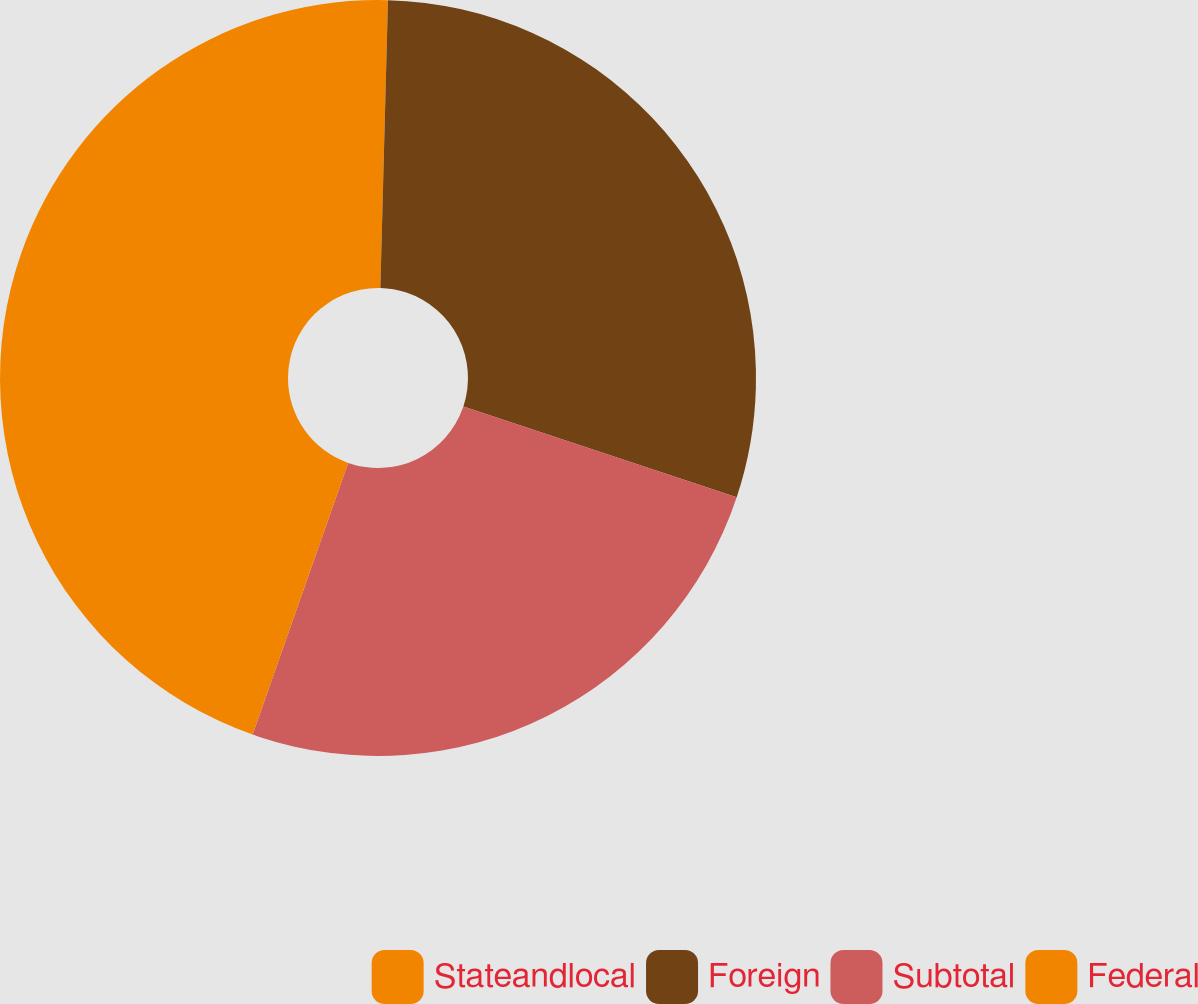<chart> <loc_0><loc_0><loc_500><loc_500><pie_chart><fcel>Stateandlocal<fcel>Foreign<fcel>Subtotal<fcel>Federal<nl><fcel>0.42%<fcel>29.69%<fcel>25.27%<fcel>44.62%<nl></chart> 